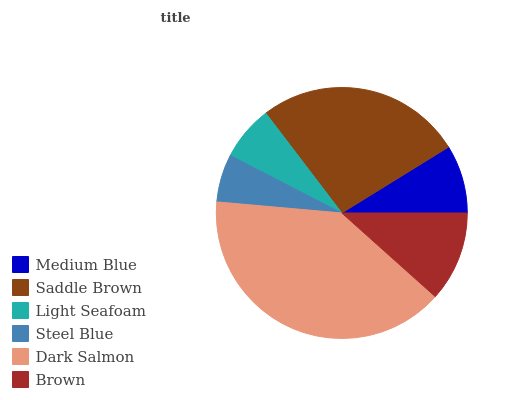Is Steel Blue the minimum?
Answer yes or no. Yes. Is Dark Salmon the maximum?
Answer yes or no. Yes. Is Saddle Brown the minimum?
Answer yes or no. No. Is Saddle Brown the maximum?
Answer yes or no. No. Is Saddle Brown greater than Medium Blue?
Answer yes or no. Yes. Is Medium Blue less than Saddle Brown?
Answer yes or no. Yes. Is Medium Blue greater than Saddle Brown?
Answer yes or no. No. Is Saddle Brown less than Medium Blue?
Answer yes or no. No. Is Brown the high median?
Answer yes or no. Yes. Is Medium Blue the low median?
Answer yes or no. Yes. Is Saddle Brown the high median?
Answer yes or no. No. Is Steel Blue the low median?
Answer yes or no. No. 